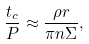<formula> <loc_0><loc_0><loc_500><loc_500>\frac { t _ { c } } { P } \approx \frac { \rho r } { \pi n \Sigma } ,</formula> 